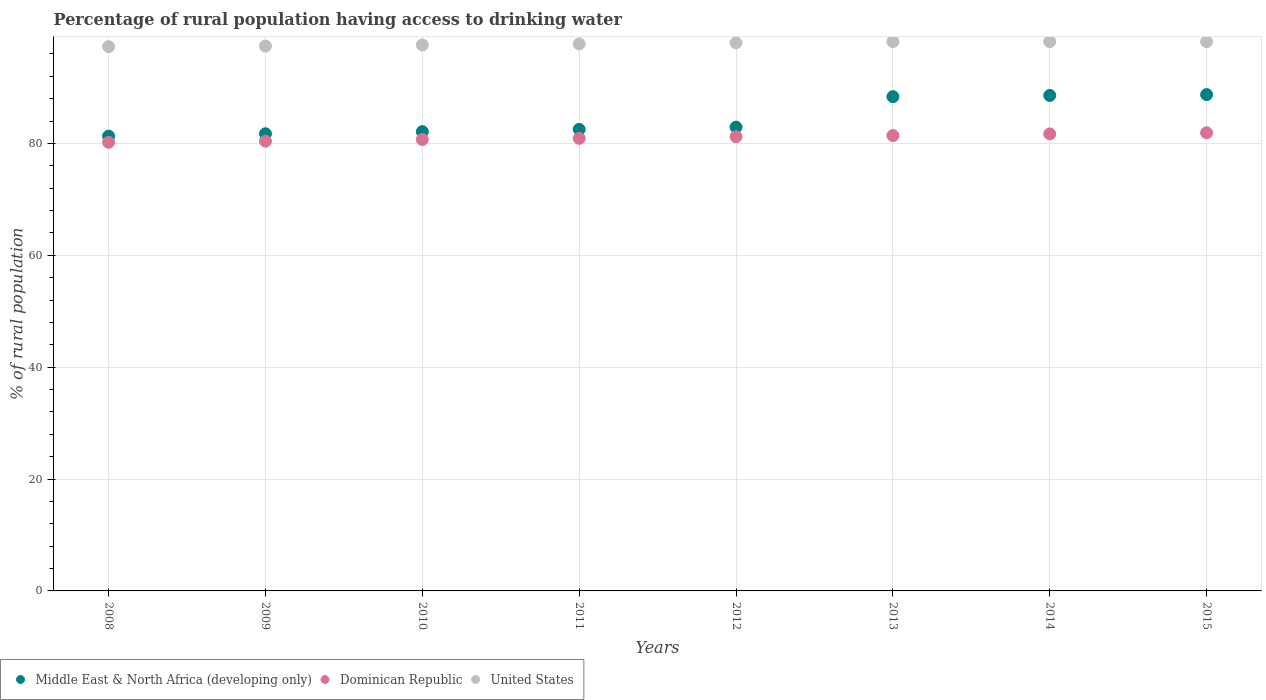What is the percentage of rural population having access to drinking water in Middle East & North Africa (developing only) in 2015?
Offer a terse response. 88.73. Across all years, what is the maximum percentage of rural population having access to drinking water in Middle East & North Africa (developing only)?
Give a very brief answer. 88.73. Across all years, what is the minimum percentage of rural population having access to drinking water in Dominican Republic?
Your response must be concise. 80.2. In which year was the percentage of rural population having access to drinking water in United States maximum?
Your response must be concise. 2013. In which year was the percentage of rural population having access to drinking water in Middle East & North Africa (developing only) minimum?
Your answer should be compact. 2008. What is the total percentage of rural population having access to drinking water in United States in the graph?
Give a very brief answer. 782.7. What is the difference between the percentage of rural population having access to drinking water in Middle East & North Africa (developing only) in 2014 and that in 2015?
Your response must be concise. -0.15. What is the difference between the percentage of rural population having access to drinking water in Middle East & North Africa (developing only) in 2008 and the percentage of rural population having access to drinking water in United States in 2012?
Your answer should be very brief. -16.7. What is the average percentage of rural population having access to drinking water in Middle East & North Africa (developing only) per year?
Your response must be concise. 84.53. In the year 2014, what is the difference between the percentage of rural population having access to drinking water in Dominican Republic and percentage of rural population having access to drinking water in United States?
Give a very brief answer. -16.5. What is the ratio of the percentage of rural population having access to drinking water in United States in 2014 to that in 2015?
Make the answer very short. 1. Is the difference between the percentage of rural population having access to drinking water in Dominican Republic in 2012 and 2015 greater than the difference between the percentage of rural population having access to drinking water in United States in 2012 and 2015?
Provide a succinct answer. No. What is the difference between the highest and the second highest percentage of rural population having access to drinking water in United States?
Give a very brief answer. 0. What is the difference between the highest and the lowest percentage of rural population having access to drinking water in Middle East & North Africa (developing only)?
Give a very brief answer. 7.43. Is the sum of the percentage of rural population having access to drinking water in United States in 2010 and 2011 greater than the maximum percentage of rural population having access to drinking water in Middle East & North Africa (developing only) across all years?
Keep it short and to the point. Yes. Is it the case that in every year, the sum of the percentage of rural population having access to drinking water in Middle East & North Africa (developing only) and percentage of rural population having access to drinking water in United States  is greater than the percentage of rural population having access to drinking water in Dominican Republic?
Offer a very short reply. Yes. Is the percentage of rural population having access to drinking water in United States strictly greater than the percentage of rural population having access to drinking water in Middle East & North Africa (developing only) over the years?
Offer a terse response. Yes. How many dotlines are there?
Keep it short and to the point. 3. Are the values on the major ticks of Y-axis written in scientific E-notation?
Your answer should be compact. No. Does the graph contain any zero values?
Keep it short and to the point. No. Does the graph contain grids?
Make the answer very short. Yes. Where does the legend appear in the graph?
Ensure brevity in your answer.  Bottom left. How many legend labels are there?
Give a very brief answer. 3. How are the legend labels stacked?
Offer a terse response. Horizontal. What is the title of the graph?
Offer a very short reply. Percentage of rural population having access to drinking water. What is the label or title of the X-axis?
Offer a very short reply. Years. What is the label or title of the Y-axis?
Give a very brief answer. % of rural population. What is the % of rural population in Middle East & North Africa (developing only) in 2008?
Your response must be concise. 81.3. What is the % of rural population of Dominican Republic in 2008?
Ensure brevity in your answer.  80.2. What is the % of rural population in United States in 2008?
Ensure brevity in your answer.  97.3. What is the % of rural population in Middle East & North Africa (developing only) in 2009?
Your answer should be very brief. 81.73. What is the % of rural population in Dominican Republic in 2009?
Give a very brief answer. 80.4. What is the % of rural population of United States in 2009?
Give a very brief answer. 97.4. What is the % of rural population of Middle East & North Africa (developing only) in 2010?
Provide a short and direct response. 82.11. What is the % of rural population in Dominican Republic in 2010?
Your answer should be very brief. 80.7. What is the % of rural population of United States in 2010?
Your answer should be compact. 97.6. What is the % of rural population in Middle East & North Africa (developing only) in 2011?
Keep it short and to the point. 82.51. What is the % of rural population in Dominican Republic in 2011?
Make the answer very short. 80.9. What is the % of rural population in United States in 2011?
Ensure brevity in your answer.  97.8. What is the % of rural population in Middle East & North Africa (developing only) in 2012?
Provide a short and direct response. 82.91. What is the % of rural population of Dominican Republic in 2012?
Keep it short and to the point. 81.2. What is the % of rural population in United States in 2012?
Your response must be concise. 98. What is the % of rural population in Middle East & North Africa (developing only) in 2013?
Your answer should be very brief. 88.36. What is the % of rural population of Dominican Republic in 2013?
Give a very brief answer. 81.4. What is the % of rural population of United States in 2013?
Keep it short and to the point. 98.2. What is the % of rural population of Middle East & North Africa (developing only) in 2014?
Your answer should be very brief. 88.57. What is the % of rural population of Dominican Republic in 2014?
Provide a short and direct response. 81.7. What is the % of rural population of United States in 2014?
Give a very brief answer. 98.2. What is the % of rural population of Middle East & North Africa (developing only) in 2015?
Ensure brevity in your answer.  88.73. What is the % of rural population of Dominican Republic in 2015?
Ensure brevity in your answer.  81.9. What is the % of rural population in United States in 2015?
Your response must be concise. 98.2. Across all years, what is the maximum % of rural population of Middle East & North Africa (developing only)?
Your response must be concise. 88.73. Across all years, what is the maximum % of rural population of Dominican Republic?
Make the answer very short. 81.9. Across all years, what is the maximum % of rural population in United States?
Keep it short and to the point. 98.2. Across all years, what is the minimum % of rural population of Middle East & North Africa (developing only)?
Make the answer very short. 81.3. Across all years, what is the minimum % of rural population of Dominican Republic?
Your response must be concise. 80.2. Across all years, what is the minimum % of rural population in United States?
Provide a short and direct response. 97.3. What is the total % of rural population of Middle East & North Africa (developing only) in the graph?
Your answer should be compact. 676.21. What is the total % of rural population in Dominican Republic in the graph?
Your answer should be compact. 648.4. What is the total % of rural population of United States in the graph?
Ensure brevity in your answer.  782.7. What is the difference between the % of rural population in Middle East & North Africa (developing only) in 2008 and that in 2009?
Give a very brief answer. -0.43. What is the difference between the % of rural population in Dominican Republic in 2008 and that in 2009?
Make the answer very short. -0.2. What is the difference between the % of rural population of Middle East & North Africa (developing only) in 2008 and that in 2010?
Your answer should be very brief. -0.81. What is the difference between the % of rural population of Middle East & North Africa (developing only) in 2008 and that in 2011?
Provide a short and direct response. -1.21. What is the difference between the % of rural population of Dominican Republic in 2008 and that in 2011?
Offer a terse response. -0.7. What is the difference between the % of rural population in United States in 2008 and that in 2011?
Offer a very short reply. -0.5. What is the difference between the % of rural population of Middle East & North Africa (developing only) in 2008 and that in 2012?
Give a very brief answer. -1.61. What is the difference between the % of rural population in Middle East & North Africa (developing only) in 2008 and that in 2013?
Offer a terse response. -7.06. What is the difference between the % of rural population in Dominican Republic in 2008 and that in 2013?
Offer a terse response. -1.2. What is the difference between the % of rural population of Middle East & North Africa (developing only) in 2008 and that in 2014?
Offer a terse response. -7.28. What is the difference between the % of rural population in Middle East & North Africa (developing only) in 2008 and that in 2015?
Provide a succinct answer. -7.43. What is the difference between the % of rural population in United States in 2008 and that in 2015?
Provide a short and direct response. -0.9. What is the difference between the % of rural population in Middle East & North Africa (developing only) in 2009 and that in 2010?
Offer a very short reply. -0.38. What is the difference between the % of rural population of Dominican Republic in 2009 and that in 2010?
Your response must be concise. -0.3. What is the difference between the % of rural population of United States in 2009 and that in 2010?
Offer a very short reply. -0.2. What is the difference between the % of rural population in Middle East & North Africa (developing only) in 2009 and that in 2011?
Your answer should be compact. -0.78. What is the difference between the % of rural population in Middle East & North Africa (developing only) in 2009 and that in 2012?
Give a very brief answer. -1.19. What is the difference between the % of rural population of Middle East & North Africa (developing only) in 2009 and that in 2013?
Your response must be concise. -6.63. What is the difference between the % of rural population of Middle East & North Africa (developing only) in 2009 and that in 2014?
Your answer should be very brief. -6.85. What is the difference between the % of rural population in Dominican Republic in 2009 and that in 2014?
Ensure brevity in your answer.  -1.3. What is the difference between the % of rural population of Middle East & North Africa (developing only) in 2009 and that in 2015?
Give a very brief answer. -7. What is the difference between the % of rural population of United States in 2009 and that in 2015?
Ensure brevity in your answer.  -0.8. What is the difference between the % of rural population in Middle East & North Africa (developing only) in 2010 and that in 2011?
Give a very brief answer. -0.4. What is the difference between the % of rural population in Dominican Republic in 2010 and that in 2011?
Provide a short and direct response. -0.2. What is the difference between the % of rural population of Middle East & North Africa (developing only) in 2010 and that in 2012?
Give a very brief answer. -0.81. What is the difference between the % of rural population in United States in 2010 and that in 2012?
Keep it short and to the point. -0.4. What is the difference between the % of rural population in Middle East & North Africa (developing only) in 2010 and that in 2013?
Your answer should be compact. -6.25. What is the difference between the % of rural population in Dominican Republic in 2010 and that in 2013?
Keep it short and to the point. -0.7. What is the difference between the % of rural population of United States in 2010 and that in 2013?
Keep it short and to the point. -0.6. What is the difference between the % of rural population in Middle East & North Africa (developing only) in 2010 and that in 2014?
Your answer should be very brief. -6.47. What is the difference between the % of rural population in Dominican Republic in 2010 and that in 2014?
Offer a very short reply. -1. What is the difference between the % of rural population in Middle East & North Africa (developing only) in 2010 and that in 2015?
Ensure brevity in your answer.  -6.62. What is the difference between the % of rural population in United States in 2010 and that in 2015?
Provide a succinct answer. -0.6. What is the difference between the % of rural population in Middle East & North Africa (developing only) in 2011 and that in 2012?
Your response must be concise. -0.41. What is the difference between the % of rural population in United States in 2011 and that in 2012?
Make the answer very short. -0.2. What is the difference between the % of rural population in Middle East & North Africa (developing only) in 2011 and that in 2013?
Provide a succinct answer. -5.85. What is the difference between the % of rural population in United States in 2011 and that in 2013?
Your answer should be compact. -0.4. What is the difference between the % of rural population in Middle East & North Africa (developing only) in 2011 and that in 2014?
Your answer should be very brief. -6.07. What is the difference between the % of rural population in United States in 2011 and that in 2014?
Give a very brief answer. -0.4. What is the difference between the % of rural population of Middle East & North Africa (developing only) in 2011 and that in 2015?
Give a very brief answer. -6.22. What is the difference between the % of rural population in Middle East & North Africa (developing only) in 2012 and that in 2013?
Give a very brief answer. -5.45. What is the difference between the % of rural population in Middle East & North Africa (developing only) in 2012 and that in 2014?
Keep it short and to the point. -5.66. What is the difference between the % of rural population in United States in 2012 and that in 2014?
Ensure brevity in your answer.  -0.2. What is the difference between the % of rural population in Middle East & North Africa (developing only) in 2012 and that in 2015?
Your response must be concise. -5.82. What is the difference between the % of rural population of Middle East & North Africa (developing only) in 2013 and that in 2014?
Ensure brevity in your answer.  -0.22. What is the difference between the % of rural population of Dominican Republic in 2013 and that in 2014?
Your response must be concise. -0.3. What is the difference between the % of rural population of United States in 2013 and that in 2014?
Ensure brevity in your answer.  0. What is the difference between the % of rural population in Middle East & North Africa (developing only) in 2013 and that in 2015?
Make the answer very short. -0.37. What is the difference between the % of rural population in Dominican Republic in 2013 and that in 2015?
Keep it short and to the point. -0.5. What is the difference between the % of rural population of Middle East & North Africa (developing only) in 2014 and that in 2015?
Keep it short and to the point. -0.15. What is the difference between the % of rural population of United States in 2014 and that in 2015?
Give a very brief answer. 0. What is the difference between the % of rural population in Middle East & North Africa (developing only) in 2008 and the % of rural population in Dominican Republic in 2009?
Your answer should be compact. 0.9. What is the difference between the % of rural population in Middle East & North Africa (developing only) in 2008 and the % of rural population in United States in 2009?
Give a very brief answer. -16.1. What is the difference between the % of rural population in Dominican Republic in 2008 and the % of rural population in United States in 2009?
Keep it short and to the point. -17.2. What is the difference between the % of rural population of Middle East & North Africa (developing only) in 2008 and the % of rural population of Dominican Republic in 2010?
Give a very brief answer. 0.6. What is the difference between the % of rural population in Middle East & North Africa (developing only) in 2008 and the % of rural population in United States in 2010?
Provide a short and direct response. -16.3. What is the difference between the % of rural population in Dominican Republic in 2008 and the % of rural population in United States in 2010?
Keep it short and to the point. -17.4. What is the difference between the % of rural population of Middle East & North Africa (developing only) in 2008 and the % of rural population of Dominican Republic in 2011?
Make the answer very short. 0.4. What is the difference between the % of rural population of Middle East & North Africa (developing only) in 2008 and the % of rural population of United States in 2011?
Provide a succinct answer. -16.5. What is the difference between the % of rural population in Dominican Republic in 2008 and the % of rural population in United States in 2011?
Ensure brevity in your answer.  -17.6. What is the difference between the % of rural population in Middle East & North Africa (developing only) in 2008 and the % of rural population in Dominican Republic in 2012?
Your response must be concise. 0.1. What is the difference between the % of rural population in Middle East & North Africa (developing only) in 2008 and the % of rural population in United States in 2012?
Provide a short and direct response. -16.7. What is the difference between the % of rural population in Dominican Republic in 2008 and the % of rural population in United States in 2012?
Make the answer very short. -17.8. What is the difference between the % of rural population of Middle East & North Africa (developing only) in 2008 and the % of rural population of Dominican Republic in 2013?
Your answer should be compact. -0.1. What is the difference between the % of rural population of Middle East & North Africa (developing only) in 2008 and the % of rural population of United States in 2013?
Your response must be concise. -16.9. What is the difference between the % of rural population in Middle East & North Africa (developing only) in 2008 and the % of rural population in Dominican Republic in 2014?
Provide a short and direct response. -0.4. What is the difference between the % of rural population in Middle East & North Africa (developing only) in 2008 and the % of rural population in United States in 2014?
Provide a succinct answer. -16.9. What is the difference between the % of rural population of Dominican Republic in 2008 and the % of rural population of United States in 2014?
Your answer should be compact. -18. What is the difference between the % of rural population of Middle East & North Africa (developing only) in 2008 and the % of rural population of Dominican Republic in 2015?
Provide a short and direct response. -0.6. What is the difference between the % of rural population in Middle East & North Africa (developing only) in 2008 and the % of rural population in United States in 2015?
Make the answer very short. -16.9. What is the difference between the % of rural population in Middle East & North Africa (developing only) in 2009 and the % of rural population in Dominican Republic in 2010?
Offer a very short reply. 1.03. What is the difference between the % of rural population of Middle East & North Africa (developing only) in 2009 and the % of rural population of United States in 2010?
Ensure brevity in your answer.  -15.87. What is the difference between the % of rural population in Dominican Republic in 2009 and the % of rural population in United States in 2010?
Offer a terse response. -17.2. What is the difference between the % of rural population of Middle East & North Africa (developing only) in 2009 and the % of rural population of Dominican Republic in 2011?
Make the answer very short. 0.83. What is the difference between the % of rural population of Middle East & North Africa (developing only) in 2009 and the % of rural population of United States in 2011?
Your response must be concise. -16.07. What is the difference between the % of rural population of Dominican Republic in 2009 and the % of rural population of United States in 2011?
Your answer should be very brief. -17.4. What is the difference between the % of rural population in Middle East & North Africa (developing only) in 2009 and the % of rural population in Dominican Republic in 2012?
Give a very brief answer. 0.53. What is the difference between the % of rural population of Middle East & North Africa (developing only) in 2009 and the % of rural population of United States in 2012?
Provide a succinct answer. -16.27. What is the difference between the % of rural population in Dominican Republic in 2009 and the % of rural population in United States in 2012?
Offer a very short reply. -17.6. What is the difference between the % of rural population of Middle East & North Africa (developing only) in 2009 and the % of rural population of Dominican Republic in 2013?
Make the answer very short. 0.33. What is the difference between the % of rural population of Middle East & North Africa (developing only) in 2009 and the % of rural population of United States in 2013?
Provide a succinct answer. -16.47. What is the difference between the % of rural population of Dominican Republic in 2009 and the % of rural population of United States in 2013?
Offer a very short reply. -17.8. What is the difference between the % of rural population of Middle East & North Africa (developing only) in 2009 and the % of rural population of Dominican Republic in 2014?
Offer a very short reply. 0.03. What is the difference between the % of rural population of Middle East & North Africa (developing only) in 2009 and the % of rural population of United States in 2014?
Offer a terse response. -16.47. What is the difference between the % of rural population of Dominican Republic in 2009 and the % of rural population of United States in 2014?
Provide a succinct answer. -17.8. What is the difference between the % of rural population of Middle East & North Africa (developing only) in 2009 and the % of rural population of Dominican Republic in 2015?
Keep it short and to the point. -0.17. What is the difference between the % of rural population of Middle East & North Africa (developing only) in 2009 and the % of rural population of United States in 2015?
Your answer should be compact. -16.47. What is the difference between the % of rural population of Dominican Republic in 2009 and the % of rural population of United States in 2015?
Provide a succinct answer. -17.8. What is the difference between the % of rural population in Middle East & North Africa (developing only) in 2010 and the % of rural population in Dominican Republic in 2011?
Your answer should be compact. 1.21. What is the difference between the % of rural population of Middle East & North Africa (developing only) in 2010 and the % of rural population of United States in 2011?
Provide a succinct answer. -15.69. What is the difference between the % of rural population of Dominican Republic in 2010 and the % of rural population of United States in 2011?
Keep it short and to the point. -17.1. What is the difference between the % of rural population in Middle East & North Africa (developing only) in 2010 and the % of rural population in Dominican Republic in 2012?
Offer a very short reply. 0.91. What is the difference between the % of rural population of Middle East & North Africa (developing only) in 2010 and the % of rural population of United States in 2012?
Your response must be concise. -15.89. What is the difference between the % of rural population of Dominican Republic in 2010 and the % of rural population of United States in 2012?
Ensure brevity in your answer.  -17.3. What is the difference between the % of rural population in Middle East & North Africa (developing only) in 2010 and the % of rural population in Dominican Republic in 2013?
Your answer should be very brief. 0.71. What is the difference between the % of rural population of Middle East & North Africa (developing only) in 2010 and the % of rural population of United States in 2013?
Make the answer very short. -16.09. What is the difference between the % of rural population of Dominican Republic in 2010 and the % of rural population of United States in 2013?
Ensure brevity in your answer.  -17.5. What is the difference between the % of rural population in Middle East & North Africa (developing only) in 2010 and the % of rural population in Dominican Republic in 2014?
Your answer should be very brief. 0.41. What is the difference between the % of rural population in Middle East & North Africa (developing only) in 2010 and the % of rural population in United States in 2014?
Ensure brevity in your answer.  -16.09. What is the difference between the % of rural population of Dominican Republic in 2010 and the % of rural population of United States in 2014?
Offer a very short reply. -17.5. What is the difference between the % of rural population in Middle East & North Africa (developing only) in 2010 and the % of rural population in Dominican Republic in 2015?
Your answer should be compact. 0.21. What is the difference between the % of rural population in Middle East & North Africa (developing only) in 2010 and the % of rural population in United States in 2015?
Provide a succinct answer. -16.09. What is the difference between the % of rural population of Dominican Republic in 2010 and the % of rural population of United States in 2015?
Your response must be concise. -17.5. What is the difference between the % of rural population in Middle East & North Africa (developing only) in 2011 and the % of rural population in Dominican Republic in 2012?
Offer a terse response. 1.31. What is the difference between the % of rural population of Middle East & North Africa (developing only) in 2011 and the % of rural population of United States in 2012?
Your response must be concise. -15.49. What is the difference between the % of rural population of Dominican Republic in 2011 and the % of rural population of United States in 2012?
Give a very brief answer. -17.1. What is the difference between the % of rural population of Middle East & North Africa (developing only) in 2011 and the % of rural population of Dominican Republic in 2013?
Your answer should be compact. 1.11. What is the difference between the % of rural population of Middle East & North Africa (developing only) in 2011 and the % of rural population of United States in 2013?
Offer a terse response. -15.69. What is the difference between the % of rural population in Dominican Republic in 2011 and the % of rural population in United States in 2013?
Offer a very short reply. -17.3. What is the difference between the % of rural population of Middle East & North Africa (developing only) in 2011 and the % of rural population of Dominican Republic in 2014?
Your answer should be compact. 0.81. What is the difference between the % of rural population in Middle East & North Africa (developing only) in 2011 and the % of rural population in United States in 2014?
Give a very brief answer. -15.69. What is the difference between the % of rural population in Dominican Republic in 2011 and the % of rural population in United States in 2014?
Keep it short and to the point. -17.3. What is the difference between the % of rural population of Middle East & North Africa (developing only) in 2011 and the % of rural population of Dominican Republic in 2015?
Your answer should be compact. 0.61. What is the difference between the % of rural population of Middle East & North Africa (developing only) in 2011 and the % of rural population of United States in 2015?
Your answer should be compact. -15.69. What is the difference between the % of rural population of Dominican Republic in 2011 and the % of rural population of United States in 2015?
Give a very brief answer. -17.3. What is the difference between the % of rural population in Middle East & North Africa (developing only) in 2012 and the % of rural population in Dominican Republic in 2013?
Your answer should be very brief. 1.51. What is the difference between the % of rural population of Middle East & North Africa (developing only) in 2012 and the % of rural population of United States in 2013?
Provide a succinct answer. -15.29. What is the difference between the % of rural population of Dominican Republic in 2012 and the % of rural population of United States in 2013?
Provide a succinct answer. -17. What is the difference between the % of rural population in Middle East & North Africa (developing only) in 2012 and the % of rural population in Dominican Republic in 2014?
Provide a succinct answer. 1.21. What is the difference between the % of rural population in Middle East & North Africa (developing only) in 2012 and the % of rural population in United States in 2014?
Offer a terse response. -15.29. What is the difference between the % of rural population in Dominican Republic in 2012 and the % of rural population in United States in 2014?
Offer a very short reply. -17. What is the difference between the % of rural population in Middle East & North Africa (developing only) in 2012 and the % of rural population in Dominican Republic in 2015?
Keep it short and to the point. 1.01. What is the difference between the % of rural population of Middle East & North Africa (developing only) in 2012 and the % of rural population of United States in 2015?
Provide a succinct answer. -15.29. What is the difference between the % of rural population in Middle East & North Africa (developing only) in 2013 and the % of rural population in Dominican Republic in 2014?
Your response must be concise. 6.66. What is the difference between the % of rural population in Middle East & North Africa (developing only) in 2013 and the % of rural population in United States in 2014?
Provide a succinct answer. -9.84. What is the difference between the % of rural population in Dominican Republic in 2013 and the % of rural population in United States in 2014?
Keep it short and to the point. -16.8. What is the difference between the % of rural population of Middle East & North Africa (developing only) in 2013 and the % of rural population of Dominican Republic in 2015?
Provide a short and direct response. 6.46. What is the difference between the % of rural population of Middle East & North Africa (developing only) in 2013 and the % of rural population of United States in 2015?
Provide a short and direct response. -9.84. What is the difference between the % of rural population of Dominican Republic in 2013 and the % of rural population of United States in 2015?
Your answer should be very brief. -16.8. What is the difference between the % of rural population of Middle East & North Africa (developing only) in 2014 and the % of rural population of Dominican Republic in 2015?
Your answer should be very brief. 6.67. What is the difference between the % of rural population of Middle East & North Africa (developing only) in 2014 and the % of rural population of United States in 2015?
Offer a terse response. -9.63. What is the difference between the % of rural population of Dominican Republic in 2014 and the % of rural population of United States in 2015?
Your answer should be compact. -16.5. What is the average % of rural population of Middle East & North Africa (developing only) per year?
Your answer should be compact. 84.53. What is the average % of rural population of Dominican Republic per year?
Offer a terse response. 81.05. What is the average % of rural population in United States per year?
Offer a terse response. 97.84. In the year 2008, what is the difference between the % of rural population of Middle East & North Africa (developing only) and % of rural population of Dominican Republic?
Your response must be concise. 1.1. In the year 2008, what is the difference between the % of rural population of Middle East & North Africa (developing only) and % of rural population of United States?
Make the answer very short. -16. In the year 2008, what is the difference between the % of rural population in Dominican Republic and % of rural population in United States?
Your answer should be compact. -17.1. In the year 2009, what is the difference between the % of rural population in Middle East & North Africa (developing only) and % of rural population in Dominican Republic?
Give a very brief answer. 1.33. In the year 2009, what is the difference between the % of rural population in Middle East & North Africa (developing only) and % of rural population in United States?
Ensure brevity in your answer.  -15.67. In the year 2009, what is the difference between the % of rural population of Dominican Republic and % of rural population of United States?
Give a very brief answer. -17. In the year 2010, what is the difference between the % of rural population of Middle East & North Africa (developing only) and % of rural population of Dominican Republic?
Ensure brevity in your answer.  1.41. In the year 2010, what is the difference between the % of rural population in Middle East & North Africa (developing only) and % of rural population in United States?
Offer a very short reply. -15.49. In the year 2010, what is the difference between the % of rural population in Dominican Republic and % of rural population in United States?
Provide a succinct answer. -16.9. In the year 2011, what is the difference between the % of rural population of Middle East & North Africa (developing only) and % of rural population of Dominican Republic?
Ensure brevity in your answer.  1.61. In the year 2011, what is the difference between the % of rural population of Middle East & North Africa (developing only) and % of rural population of United States?
Your response must be concise. -15.29. In the year 2011, what is the difference between the % of rural population of Dominican Republic and % of rural population of United States?
Provide a succinct answer. -16.9. In the year 2012, what is the difference between the % of rural population of Middle East & North Africa (developing only) and % of rural population of Dominican Republic?
Keep it short and to the point. 1.71. In the year 2012, what is the difference between the % of rural population of Middle East & North Africa (developing only) and % of rural population of United States?
Provide a short and direct response. -15.09. In the year 2012, what is the difference between the % of rural population in Dominican Republic and % of rural population in United States?
Offer a very short reply. -16.8. In the year 2013, what is the difference between the % of rural population in Middle East & North Africa (developing only) and % of rural population in Dominican Republic?
Your answer should be very brief. 6.96. In the year 2013, what is the difference between the % of rural population in Middle East & North Africa (developing only) and % of rural population in United States?
Offer a very short reply. -9.84. In the year 2013, what is the difference between the % of rural population of Dominican Republic and % of rural population of United States?
Make the answer very short. -16.8. In the year 2014, what is the difference between the % of rural population of Middle East & North Africa (developing only) and % of rural population of Dominican Republic?
Offer a very short reply. 6.87. In the year 2014, what is the difference between the % of rural population of Middle East & North Africa (developing only) and % of rural population of United States?
Offer a very short reply. -9.63. In the year 2014, what is the difference between the % of rural population in Dominican Republic and % of rural population in United States?
Provide a succinct answer. -16.5. In the year 2015, what is the difference between the % of rural population in Middle East & North Africa (developing only) and % of rural population in Dominican Republic?
Ensure brevity in your answer.  6.83. In the year 2015, what is the difference between the % of rural population in Middle East & North Africa (developing only) and % of rural population in United States?
Your response must be concise. -9.47. In the year 2015, what is the difference between the % of rural population in Dominican Republic and % of rural population in United States?
Ensure brevity in your answer.  -16.3. What is the ratio of the % of rural population of Middle East & North Africa (developing only) in 2008 to that in 2010?
Give a very brief answer. 0.99. What is the ratio of the % of rural population in Dominican Republic in 2008 to that in 2010?
Make the answer very short. 0.99. What is the ratio of the % of rural population in United States in 2008 to that in 2010?
Keep it short and to the point. 1. What is the ratio of the % of rural population in Dominican Republic in 2008 to that in 2011?
Your answer should be compact. 0.99. What is the ratio of the % of rural population of United States in 2008 to that in 2011?
Make the answer very short. 0.99. What is the ratio of the % of rural population of Middle East & North Africa (developing only) in 2008 to that in 2012?
Your answer should be compact. 0.98. What is the ratio of the % of rural population in Dominican Republic in 2008 to that in 2012?
Your answer should be compact. 0.99. What is the ratio of the % of rural population in United States in 2008 to that in 2012?
Your answer should be very brief. 0.99. What is the ratio of the % of rural population in Middle East & North Africa (developing only) in 2008 to that in 2013?
Your answer should be compact. 0.92. What is the ratio of the % of rural population in Dominican Republic in 2008 to that in 2013?
Keep it short and to the point. 0.99. What is the ratio of the % of rural population in Middle East & North Africa (developing only) in 2008 to that in 2014?
Provide a short and direct response. 0.92. What is the ratio of the % of rural population in Dominican Republic in 2008 to that in 2014?
Your answer should be very brief. 0.98. What is the ratio of the % of rural population in Middle East & North Africa (developing only) in 2008 to that in 2015?
Offer a very short reply. 0.92. What is the ratio of the % of rural population of Dominican Republic in 2008 to that in 2015?
Keep it short and to the point. 0.98. What is the ratio of the % of rural population in United States in 2008 to that in 2015?
Your answer should be compact. 0.99. What is the ratio of the % of rural population in Dominican Republic in 2009 to that in 2010?
Keep it short and to the point. 1. What is the ratio of the % of rural population of United States in 2009 to that in 2010?
Give a very brief answer. 1. What is the ratio of the % of rural population of Middle East & North Africa (developing only) in 2009 to that in 2011?
Make the answer very short. 0.99. What is the ratio of the % of rural population of United States in 2009 to that in 2011?
Make the answer very short. 1. What is the ratio of the % of rural population in Middle East & North Africa (developing only) in 2009 to that in 2012?
Offer a very short reply. 0.99. What is the ratio of the % of rural population in United States in 2009 to that in 2012?
Your answer should be very brief. 0.99. What is the ratio of the % of rural population of Middle East & North Africa (developing only) in 2009 to that in 2013?
Your answer should be compact. 0.92. What is the ratio of the % of rural population of Dominican Republic in 2009 to that in 2013?
Offer a terse response. 0.99. What is the ratio of the % of rural population of Middle East & North Africa (developing only) in 2009 to that in 2014?
Your answer should be very brief. 0.92. What is the ratio of the % of rural population in Dominican Republic in 2009 to that in 2014?
Your answer should be very brief. 0.98. What is the ratio of the % of rural population in United States in 2009 to that in 2014?
Offer a very short reply. 0.99. What is the ratio of the % of rural population in Middle East & North Africa (developing only) in 2009 to that in 2015?
Give a very brief answer. 0.92. What is the ratio of the % of rural population of Dominican Republic in 2009 to that in 2015?
Provide a succinct answer. 0.98. What is the ratio of the % of rural population in United States in 2010 to that in 2011?
Your response must be concise. 1. What is the ratio of the % of rural population in Middle East & North Africa (developing only) in 2010 to that in 2012?
Provide a succinct answer. 0.99. What is the ratio of the % of rural population of Dominican Republic in 2010 to that in 2012?
Keep it short and to the point. 0.99. What is the ratio of the % of rural population in United States in 2010 to that in 2012?
Provide a succinct answer. 1. What is the ratio of the % of rural population of Middle East & North Africa (developing only) in 2010 to that in 2013?
Offer a very short reply. 0.93. What is the ratio of the % of rural population of United States in 2010 to that in 2013?
Provide a succinct answer. 0.99. What is the ratio of the % of rural population in Middle East & North Africa (developing only) in 2010 to that in 2014?
Your answer should be very brief. 0.93. What is the ratio of the % of rural population in Dominican Republic in 2010 to that in 2014?
Your response must be concise. 0.99. What is the ratio of the % of rural population in United States in 2010 to that in 2014?
Provide a succinct answer. 0.99. What is the ratio of the % of rural population in Middle East & North Africa (developing only) in 2010 to that in 2015?
Ensure brevity in your answer.  0.93. What is the ratio of the % of rural population of United States in 2010 to that in 2015?
Make the answer very short. 0.99. What is the ratio of the % of rural population of Middle East & North Africa (developing only) in 2011 to that in 2012?
Make the answer very short. 1. What is the ratio of the % of rural population in United States in 2011 to that in 2012?
Give a very brief answer. 1. What is the ratio of the % of rural population of Middle East & North Africa (developing only) in 2011 to that in 2013?
Ensure brevity in your answer.  0.93. What is the ratio of the % of rural population of Middle East & North Africa (developing only) in 2011 to that in 2014?
Provide a short and direct response. 0.93. What is the ratio of the % of rural population of Dominican Republic in 2011 to that in 2014?
Provide a short and direct response. 0.99. What is the ratio of the % of rural population of Middle East & North Africa (developing only) in 2011 to that in 2015?
Offer a very short reply. 0.93. What is the ratio of the % of rural population of Dominican Republic in 2011 to that in 2015?
Give a very brief answer. 0.99. What is the ratio of the % of rural population of United States in 2011 to that in 2015?
Your response must be concise. 1. What is the ratio of the % of rural population of Middle East & North Africa (developing only) in 2012 to that in 2013?
Offer a terse response. 0.94. What is the ratio of the % of rural population of Dominican Republic in 2012 to that in 2013?
Ensure brevity in your answer.  1. What is the ratio of the % of rural population of Middle East & North Africa (developing only) in 2012 to that in 2014?
Your answer should be compact. 0.94. What is the ratio of the % of rural population in Dominican Republic in 2012 to that in 2014?
Provide a succinct answer. 0.99. What is the ratio of the % of rural population of United States in 2012 to that in 2014?
Offer a terse response. 1. What is the ratio of the % of rural population of Middle East & North Africa (developing only) in 2012 to that in 2015?
Provide a succinct answer. 0.93. What is the ratio of the % of rural population of Middle East & North Africa (developing only) in 2013 to that in 2015?
Keep it short and to the point. 1. What is the ratio of the % of rural population of Dominican Republic in 2013 to that in 2015?
Provide a succinct answer. 0.99. What is the ratio of the % of rural population of United States in 2013 to that in 2015?
Make the answer very short. 1. What is the ratio of the % of rural population in Middle East & North Africa (developing only) in 2014 to that in 2015?
Your response must be concise. 1. What is the difference between the highest and the second highest % of rural population in Middle East & North Africa (developing only)?
Offer a very short reply. 0.15. What is the difference between the highest and the second highest % of rural population of Dominican Republic?
Provide a short and direct response. 0.2. What is the difference between the highest and the lowest % of rural population of Middle East & North Africa (developing only)?
Your response must be concise. 7.43. What is the difference between the highest and the lowest % of rural population in United States?
Provide a succinct answer. 0.9. 